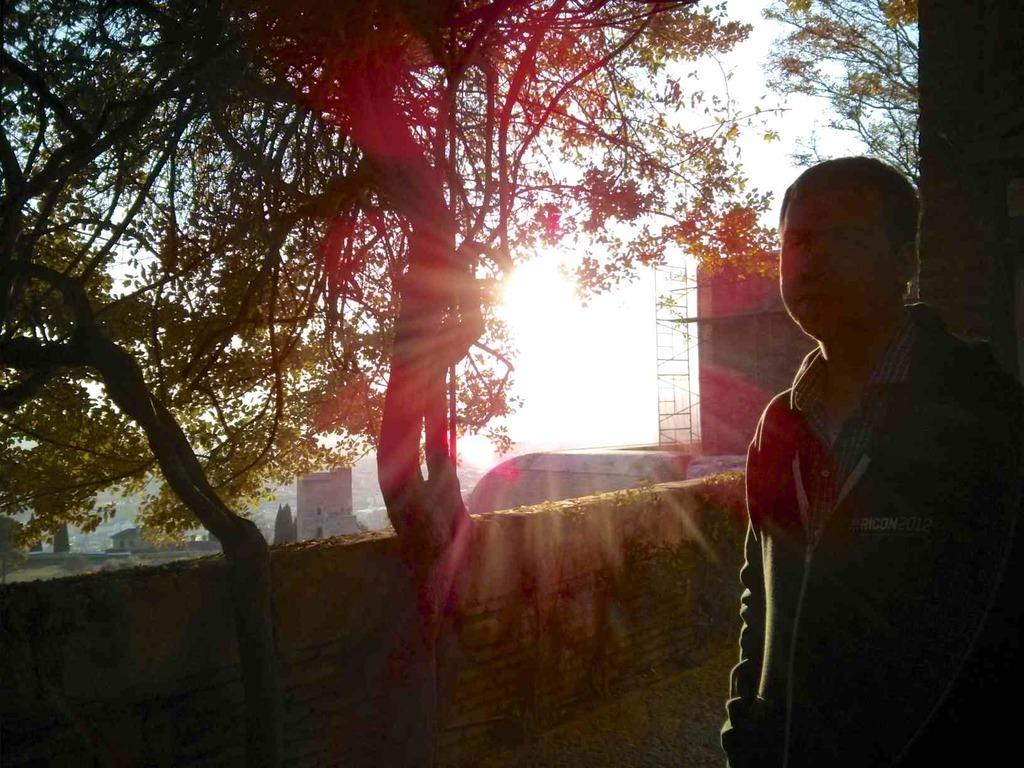What is the main subject in the image? There is a man standing in the image. What can be seen behind the man? There is a wall in the image. What type of structures are visible in the image? There are buildings in the image. What other natural elements can be seen in the image? There are trees in the image. What is visible in the background of the image? The sky is visible in the background of the image. Where is the pin located in the image? There is no pin present in the image. What type of food is being served in the lunchroom in the image? There is no lunchroom present in the image. 